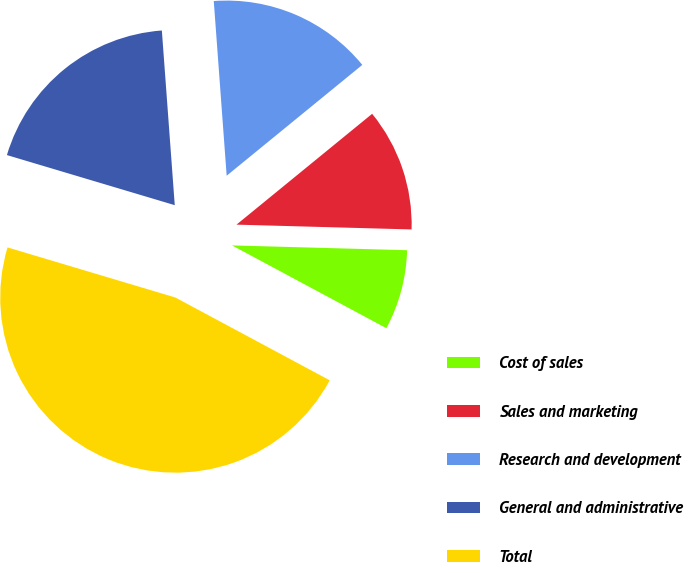Convert chart to OTSL. <chart><loc_0><loc_0><loc_500><loc_500><pie_chart><fcel>Cost of sales<fcel>Sales and marketing<fcel>Research and development<fcel>General and administrative<fcel>Total<nl><fcel>7.4%<fcel>11.34%<fcel>15.27%<fcel>19.21%<fcel>46.78%<nl></chart> 